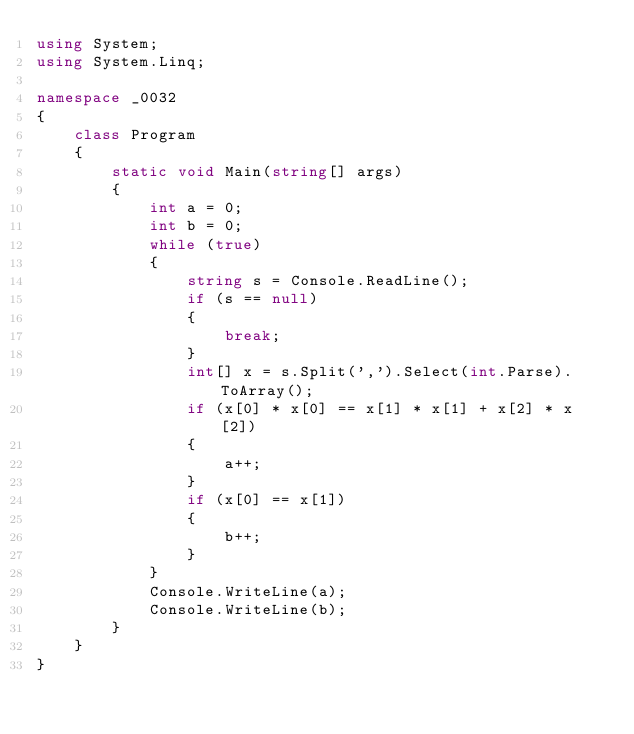Convert code to text. <code><loc_0><loc_0><loc_500><loc_500><_C#_>using System;
using System.Linq;

namespace _0032
{
    class Program
    {
        static void Main(string[] args)
        {
            int a = 0;
            int b = 0;
            while (true)
            {
                string s = Console.ReadLine();
                if (s == null)
                {
                    break;
                }
                int[] x = s.Split(',').Select(int.Parse).ToArray();
                if (x[0] * x[0] == x[1] * x[1] + x[2] * x[2])
                {
                    a++;
                }
                if (x[0] == x[1])
                {
                    b++;
                }
            }
            Console.WriteLine(a);
            Console.WriteLine(b);
        }
    }
}</code> 